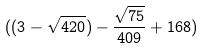<formula> <loc_0><loc_0><loc_500><loc_500>( ( 3 - \sqrt { 4 2 0 } ) - \frac { \sqrt { 7 5 } } { 4 0 9 } + 1 6 8 )</formula> 